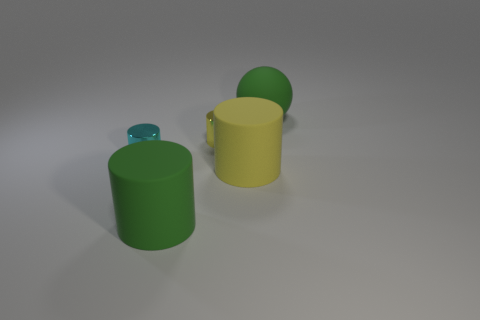There is another small cylinder that is made of the same material as the tiny cyan cylinder; what color is it?
Provide a succinct answer. Yellow. How many gray objects are either large cylinders or cylinders?
Offer a very short reply. 0. Are there more green objects than large green spheres?
Make the answer very short. Yes. What number of things are either green rubber objects that are in front of the yellow matte thing or metallic cylinders on the right side of the tiny cyan shiny object?
Your answer should be compact. 2. The rubber cylinder that is the same size as the yellow matte thing is what color?
Offer a terse response. Green. Are the tiny yellow cylinder and the small cyan cylinder made of the same material?
Your answer should be compact. Yes. What is the material of the large thing that is to the left of the yellow cylinder in front of the tiny cyan object?
Make the answer very short. Rubber. Is the number of tiny metal cylinders that are to the right of the yellow shiny thing greater than the number of large yellow metallic cubes?
Your response must be concise. No. How many other things are there of the same size as the cyan metallic cylinder?
Provide a succinct answer. 1. There is a object that is to the left of the green rubber thing to the left of the small shiny object to the right of the tiny cyan shiny cylinder; what is its color?
Offer a terse response. Cyan. 